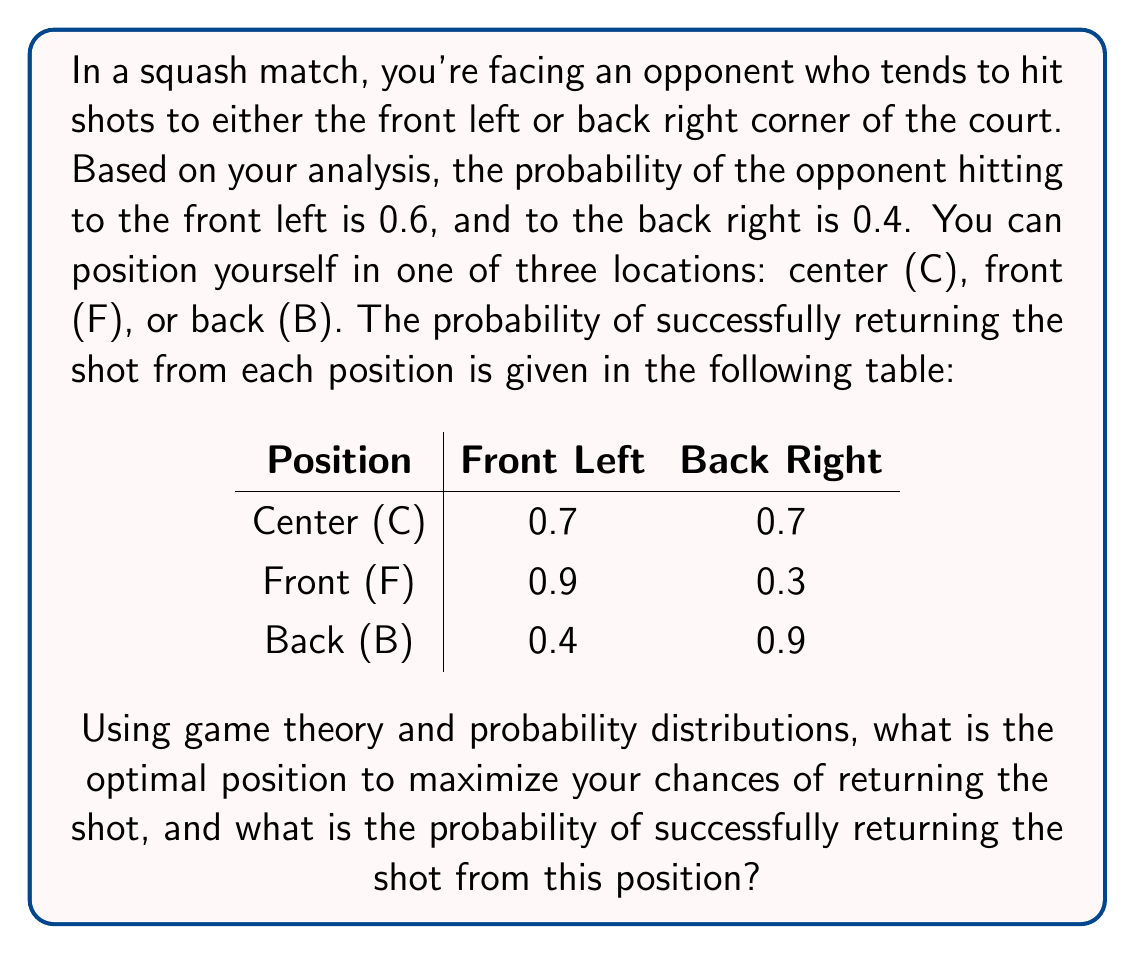Give your solution to this math problem. To solve this problem, we'll use the concept of expected value from probability theory and the minimax principle from game theory.

Step 1: Calculate the expected probability of returning the shot for each position.

For Center (C):
$E(C) = 0.6 \times 0.7 + 0.4 \times 0.7 = 0.7$

For Front (F):
$E(F) = 0.6 \times 0.9 + 0.4 \times 0.3 = 0.66$

For Back (B):
$E(B) = 0.6 \times 0.4 + 0.4 \times 0.9 = 0.6$

Step 2: Apply the minimax principle to choose the position that maximizes the minimum probability of returning the shot.

The maximum of the expected probabilities is 0.7, corresponding to the Center position.

Step 3: Verify that this is indeed the optimal strategy by considering mixed strategies.

Let $p$ be the probability of positioning at the front, and $q$ be the probability of positioning at the back. Then $1-p-q$ is the probability of positioning at the center.

The expected probability of returning the shot is:
$$E = 0.7(1-p-q) + 0.66p + 0.6q$$

To find the optimal mixed strategy, we need to solve:
$$\frac{\partial E}{\partial p} = -0.7 + 0.66 = -0.04 < 0$$
$$\frac{\partial E}{\partial q} = -0.7 + 0.6 = -0.1 < 0$$

Both partial derivatives are negative, which means the optimal strategy is to minimize both $p$ and $q$, i.e., set them to 0. This confirms that the pure strategy of always positioning at the center is optimal.

Therefore, the optimal position is Center (C), and the probability of successfully returning the shot from this position is 0.7.
Answer: Center position; 0.7 